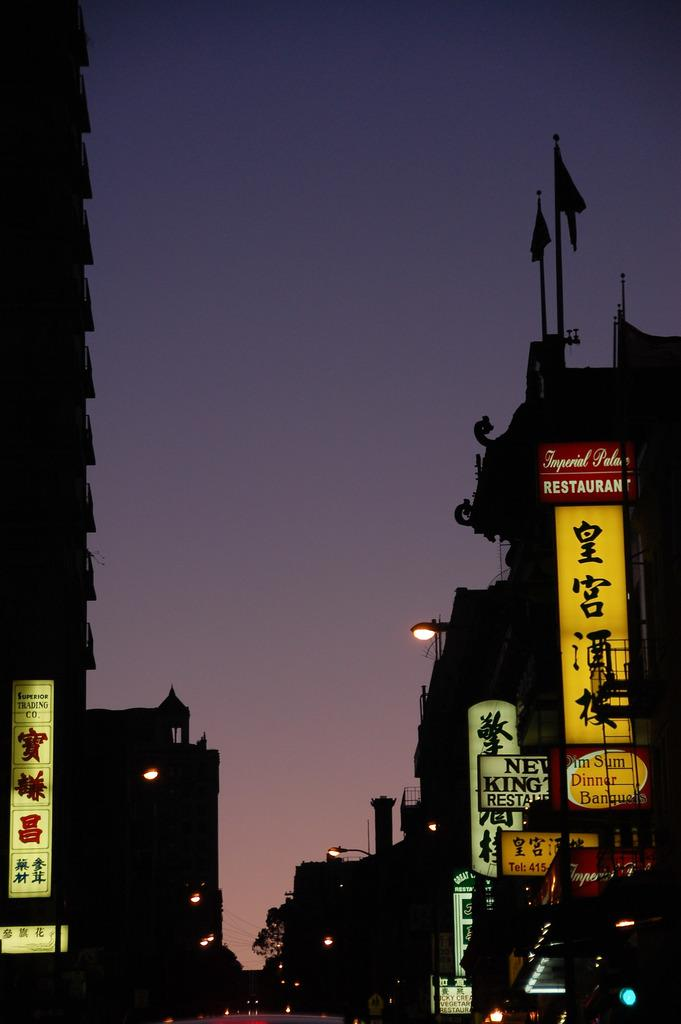<image>
Provide a brief description of the given image. a street scene in twilight with signs for Imperial Palace and Dim Sum Dinner 